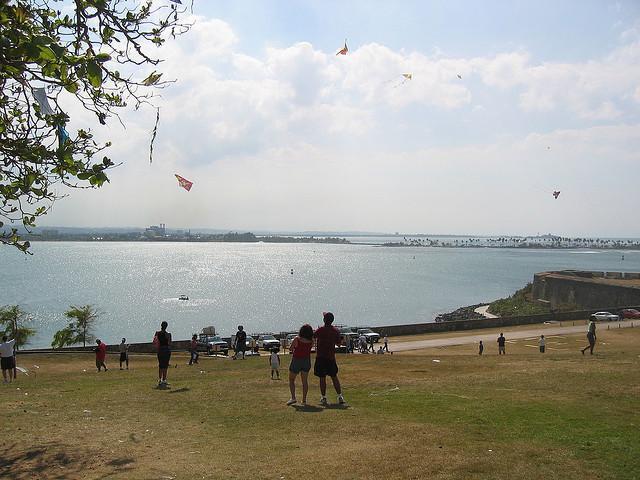How many kites are in the sky?
Give a very brief answer. 5. How many boats are in the water?
Give a very brief answer. 1. How many levels does the bus have?
Give a very brief answer. 0. 